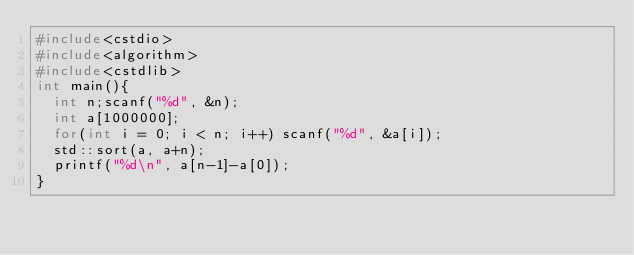Convert code to text. <code><loc_0><loc_0><loc_500><loc_500><_C++_>#include<cstdio>
#include<algorithm>
#include<cstdlib>
int main(){
  int n;scanf("%d", &n);
  int a[1000000];
  for(int i = 0; i < n; i++) scanf("%d", &a[i]);
  std::sort(a, a+n);
  printf("%d\n", a[n-1]-a[0]);
}

</code> 